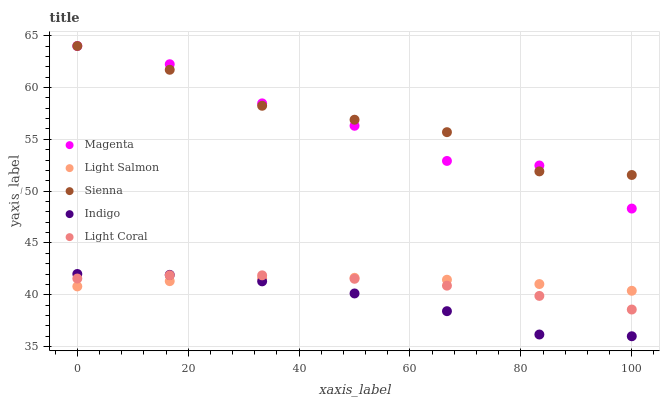Does Indigo have the minimum area under the curve?
Answer yes or no. Yes. Does Sienna have the maximum area under the curve?
Answer yes or no. Yes. Does Light Coral have the minimum area under the curve?
Answer yes or no. No. Does Light Coral have the maximum area under the curve?
Answer yes or no. No. Is Light Salmon the smoothest?
Answer yes or no. Yes. Is Magenta the roughest?
Answer yes or no. Yes. Is Light Coral the smoothest?
Answer yes or no. No. Is Light Coral the roughest?
Answer yes or no. No. Does Indigo have the lowest value?
Answer yes or no. Yes. Does Light Coral have the lowest value?
Answer yes or no. No. Does Magenta have the highest value?
Answer yes or no. Yes. Does Light Coral have the highest value?
Answer yes or no. No. Is Light Coral less than Magenta?
Answer yes or no. Yes. Is Magenta greater than Indigo?
Answer yes or no. Yes. Does Sienna intersect Magenta?
Answer yes or no. Yes. Is Sienna less than Magenta?
Answer yes or no. No. Is Sienna greater than Magenta?
Answer yes or no. No. Does Light Coral intersect Magenta?
Answer yes or no. No. 